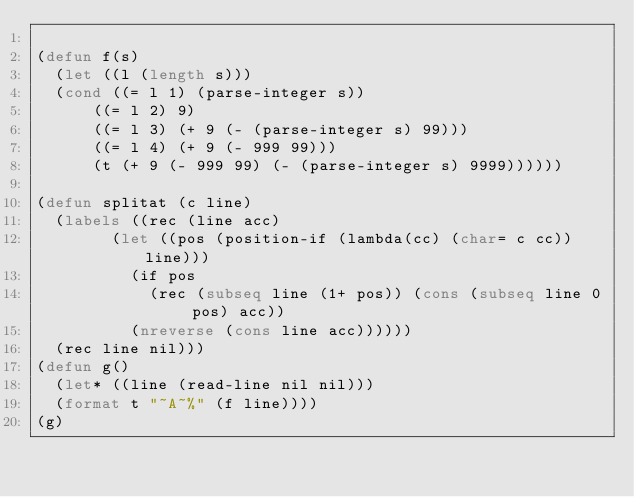Convert code to text. <code><loc_0><loc_0><loc_500><loc_500><_Lisp_>
(defun f(s)
  (let ((l (length s)))
	(cond ((= l 1) (parse-integer s))
		  ((= l 2) 9)
		  ((= l 3) (+ 9 (- (parse-integer s) 99)))
		  ((= l 4) (+ 9 (- 999 99)))
		  (t (+ 9 (- 999 99) (- (parse-integer s) 9999))))))

(defun splitat (c line)
  (labels ((rec (line acc)
				(let ((pos (position-if (lambda(cc) (char= c cc)) line)))
				  (if pos
					  (rec (subseq line (1+ pos)) (cons (subseq line 0 pos) acc))
					(nreverse (cons line acc))))))
	(rec line nil)))
(defun g()
  (let* ((line (read-line nil nil)))
  (format t "~A~%" (f line))))
(g)
</code> 